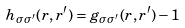Convert formula to latex. <formula><loc_0><loc_0><loc_500><loc_500>h _ { \sigma \sigma ^ { \prime } } ( { r } , { r } ^ { \prime } ) = g _ { \sigma \sigma ^ { \prime } } ( { r } , { r } ^ { \prime } ) - 1</formula> 